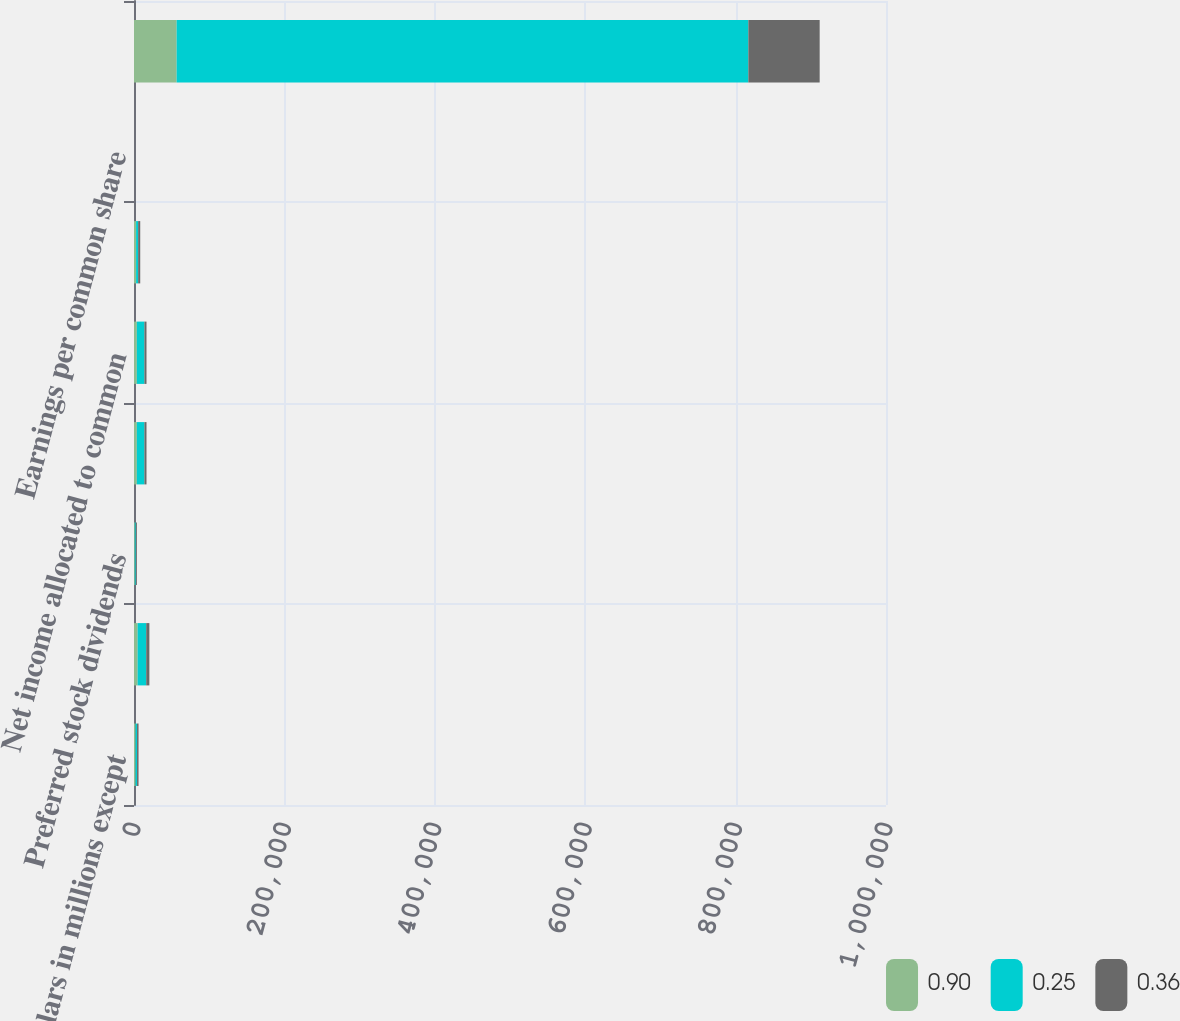<chart> <loc_0><loc_0><loc_500><loc_500><stacked_bar_chart><ecel><fcel>(Dollars in millions except<fcel>Net income<fcel>Preferred stock dividends<fcel>Net income applicable to<fcel>Net income allocated to common<fcel>Average common shares issued<fcel>Earnings per common share<fcel>Dilutive potential common<nl><fcel>0.9<fcel>2014<fcel>4833<fcel>1044<fcel>3789<fcel>3789<fcel>2760<fcel>0.36<fcel>56717<nl><fcel>0.25<fcel>2013<fcel>11431<fcel>1349<fcel>10082<fcel>10080<fcel>2760<fcel>0.94<fcel>760253<nl><fcel>0.36<fcel>2012<fcel>4188<fcel>1428<fcel>2760<fcel>2758<fcel>2760<fcel>0.26<fcel>94826<nl></chart> 